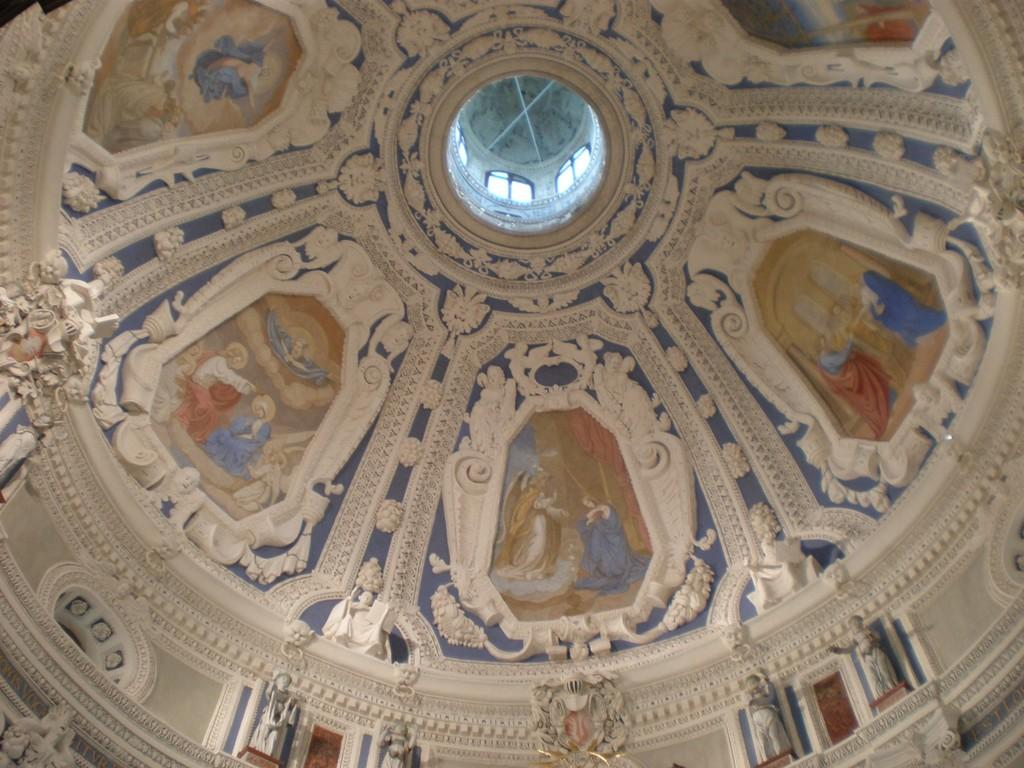What is the main structure visible in the image? There is a dome in the image. To which building does the dome belong? The dome belongs to a building. What decorative elements can be seen on the dome? There are sculptures on the dome. What type of cheese is being served for dinner in the image? There is no dinner or cheese present in the image; it features a dome with sculptures on a building. 